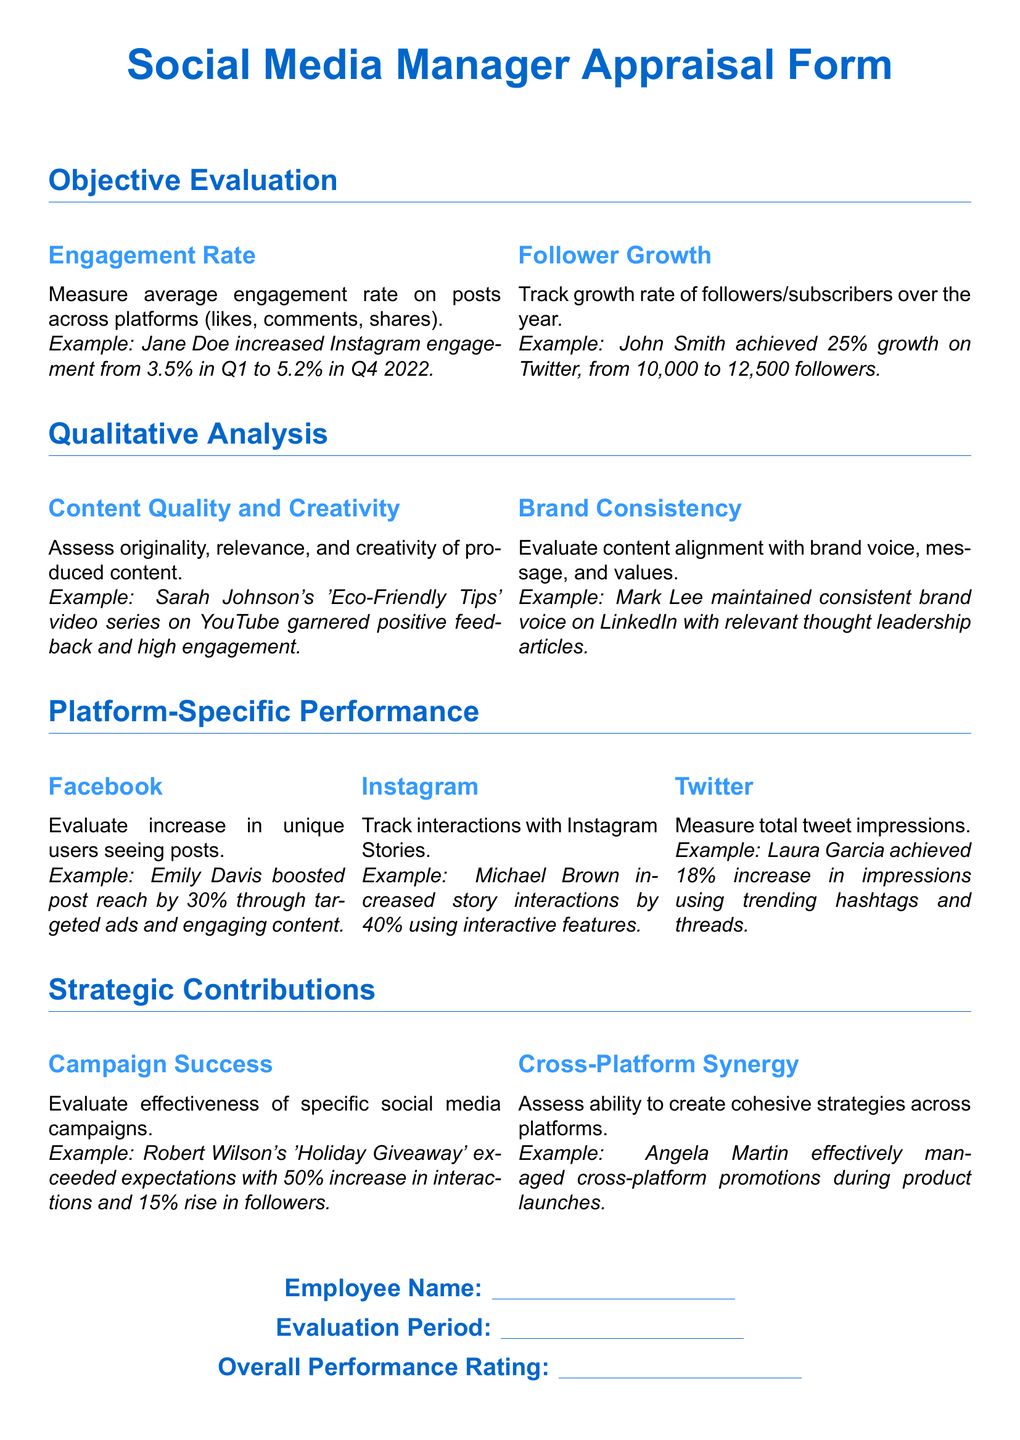What is the main focus of this appraisal form? The appraisal form centers on evaluating social media managers' effectiveness in performance metrics over the year 2022.
Answer: Evaluating social media managers' effectiveness What is the engagement rate example provided? The document includes an example showing a specific engagement rate increase from Q1 to Q4 for Jane Doe.
Answer: 3.5% to 5.2% Who achieved 25% growth on Twitter? The document cites John Smith as an individual who achieved significant growth on the platform, specifically mentioning his follower count.
Answer: John Smith What platform-specific performance is evaluated for Instagram? The appraisal looks at interactions with Instagram Stories as a key performance measure for social media managers.
Answer: Interactions with Instagram Stories What campaign is highlighted in the strategic contributions section? The appraisal provides a specific campaign example related to a holiday promotion that saw increased interactions and follower growth.
Answer: Holiday Giveaway How are cross-platform strategies assessed? The document discusses the ability to create cohesive strategies across different social media platforms, emphasizing collaborative effectiveness in promotions.
Answer: Cohesive strategies across platforms What is the subtitle for content assessment in qualitative analysis? This section assesses the originality, relevance, and creativity of the content produced by social media managers.
Answer: Content Quality and Creativity 